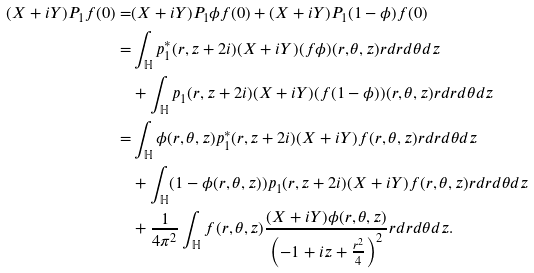<formula> <loc_0><loc_0><loc_500><loc_500>( X + i Y ) P _ { 1 } f ( 0 ) = & ( X + i Y ) P _ { 1 } \phi f ( 0 ) + ( X + i Y ) P _ { 1 } ( 1 - \phi ) f ( 0 ) \\ = & \int _ { \mathbb { H } } p ^ { * } _ { 1 } ( r , z + 2 i ) ( X + i Y ) ( f \phi ) ( r , \theta , z ) r d r d \theta d z \\ & + \int _ { \mathbb { H } } p _ { 1 } ( r , z + 2 i ) ( X + i Y ) ( f ( 1 - \phi ) ) ( r , \theta , z ) r d r d \theta d z \\ = & \int _ { \mathbb { H } } \phi ( r , \theta , z ) p ^ { * } _ { 1 } ( r , z + 2 i ) ( X + i Y ) f ( r , \theta , z ) r d r d \theta d z \\ & + \int _ { \mathbb { H } } ( 1 - \phi ( r , \theta , z ) ) p _ { 1 } ( r , z + 2 i ) ( X + i Y ) f ( r , \theta , z ) r d r d \theta d z \\ & + \frac { 1 } { 4 \pi ^ { 2 } } \int _ { \mathbb { H } } f ( r , \theta , z ) \frac { ( X + i Y ) \phi ( r , \theta , z ) } { \left ( - 1 + i z + \frac { r ^ { 2 } } { 4 } \right ) ^ { 2 } } r d r d \theta d z .</formula> 